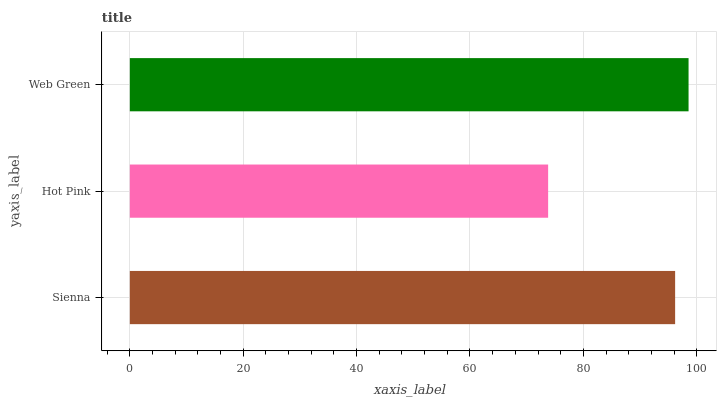Is Hot Pink the minimum?
Answer yes or no. Yes. Is Web Green the maximum?
Answer yes or no. Yes. Is Web Green the minimum?
Answer yes or no. No. Is Hot Pink the maximum?
Answer yes or no. No. Is Web Green greater than Hot Pink?
Answer yes or no. Yes. Is Hot Pink less than Web Green?
Answer yes or no. Yes. Is Hot Pink greater than Web Green?
Answer yes or no. No. Is Web Green less than Hot Pink?
Answer yes or no. No. Is Sienna the high median?
Answer yes or no. Yes. Is Sienna the low median?
Answer yes or no. Yes. Is Hot Pink the high median?
Answer yes or no. No. Is Web Green the low median?
Answer yes or no. No. 